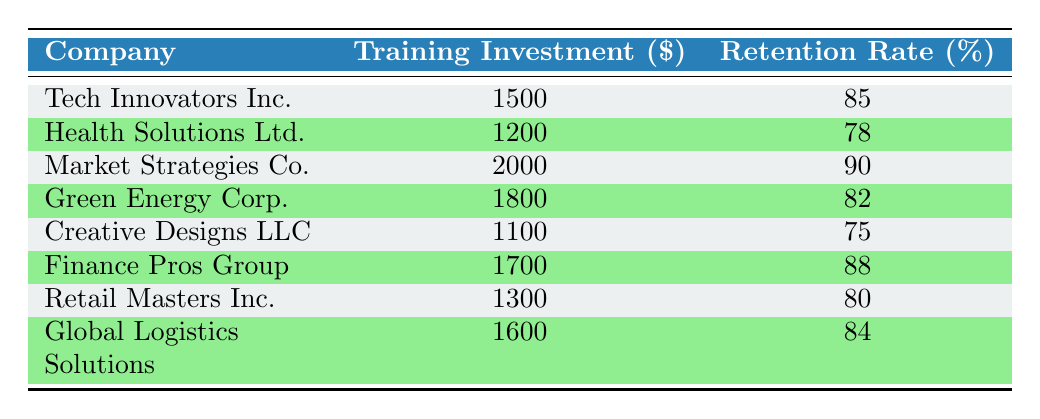What is the Training Investment per Employee for Market Strategies Co.? Market Strategies Co. has a Training Investment of 2000. This value can be found directly in the table under the "Training Investment" column for the corresponding company.
Answer: 2000 Which company has the highest Employee Retention Rate? Upon reviewing the Employee Retention Rate column, Market Strategies Co. has the highest Retention Rate at 90%. This is the greatest value listed in the respective column.
Answer: Market Strategies Co What is the average Training Investment per Employee across all companies? To find the average, we sum the Training Investments: (1500 + 1200 + 2000 + 1800 + 1100 + 1700 + 1300 + 1600) = 12200. There are 8 companies, so the average is 12200 / 8 = 1525.
Answer: 1525 Is there a correlation between higher Training Investment and higher Employee Retention Rate? Analyzing the data, we can see that as the Training Investments increase, the Employee Retention Rates generally increase as well, indicating a possible positive correlation. However, a definitive conclusion would require statistical analysis.
Answer: Yes Which two companies have the closest Training Investment values? Comparing the table entries, the two companies with the closest Training Investment values are Creative Designs LLC at 1100 and Health Solutions Ltd. at 1200. The difference is only 100.
Answer: Creative Designs LLC and Health Solutions Ltd How much higher is the Employee Retention Rate for Finance Pros Group compared to Creative Designs LLC? Finance Pros Group has a Retention Rate of 88%, while Creative Designs LLC has a Retention Rate of 75%. The difference is calculated by subtracting: 88 - 75 = 13.
Answer: 13 Which company has a Training Investment greater than 1600 but less than 1800? Referring to the table, Finance Pros Group with a Training Investment of 1700 falls between 1600 and 1800.
Answer: Finance Pros Group What is the Employee Retention Rate for the company with the lowest Training Investment? The company with the lowest Training Investment is Creative Designs LLC at 1100. Its corresponding Employee Retention Rate is 75%. Thus, the answer is found directly in the table.
Answer: 75 